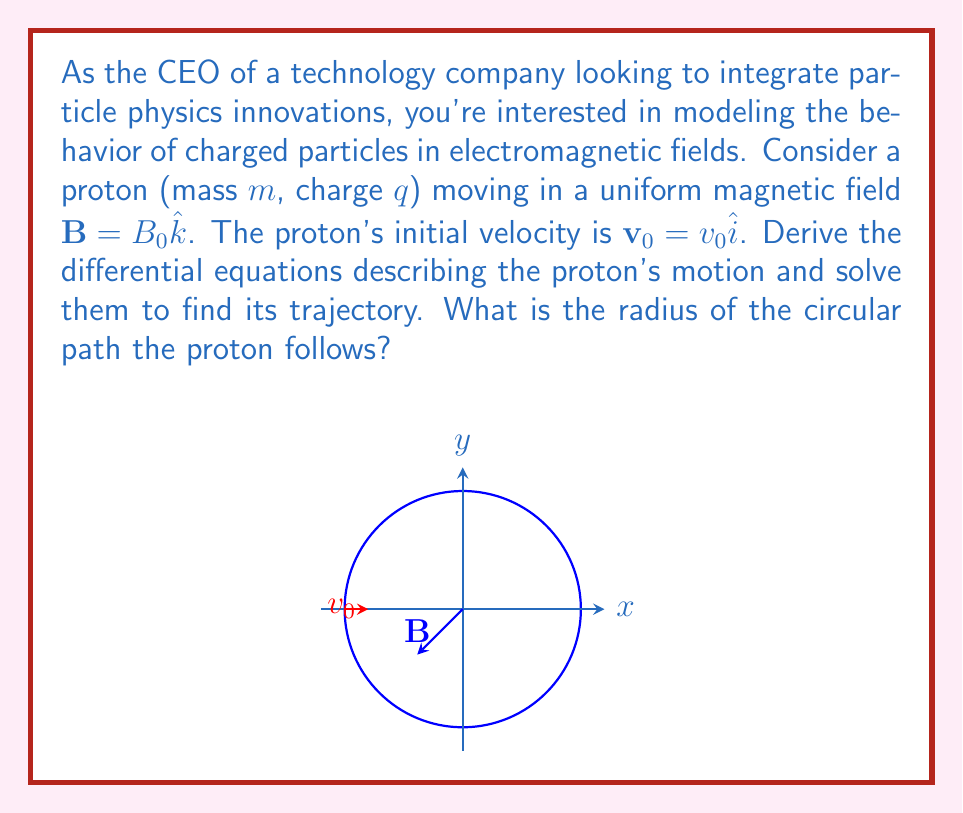Teach me how to tackle this problem. Let's approach this step-by-step:

1) The force on a charged particle in a magnetic field is given by the Lorentz force equation:
   $$\mathbf{F} = q(\mathbf{v} \times \mathbf{B})$$

2) Using Newton's second law, we can write:
   $$m\frac{d\mathbf{v}}{dt} = q(\mathbf{v} \times \mathbf{B})$$

3) Expanding this into components:
   $$m\frac{dv_x}{dt} = qB_0v_y$$
   $$m\frac{dv_y}{dt} = -qB_0v_x$$
   $$m\frac{dv_z}{dt} = 0$$

4) These are our differential equations. To solve them, we can differentiate the first equation:
   $$m\frac{d^2v_x}{dt^2} = qB_0\frac{dv_y}{dt} = -\frac{q^2B_0^2}{m}v_x$$

5) This is a simple harmonic oscillator equation with angular frequency $\omega = \frac{qB_0}{m}$. The general solution is:
   $$v_x = A\cos(\omega t) + B\sin(\omega t)$$

6) Given the initial condition $v_x(0) = v_0$, we find $A = v_0$ and $B = 0$. So:
   $$v_x = v_0\cos(\omega t)$$
   $$v_y = v_0\sin(\omega t)$$

7) Integrating these, we get the position:
   $$x = \frac{v_0}{\omega}\sin(\omega t) + C$$
   $$y = -\frac{v_0}{\omega}\cos(\omega t) + D$$

8) These equations describe a circular path. The radius of this path is:
   $$r = \frac{v_0}{\omega} = \frac{mv_0}{qB_0}$$

This radius is also known as the cyclotron radius or Larmor radius.
Answer: $$r = \frac{mv_0}{qB_0}$$ 